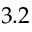Convert formula to latex. <formula><loc_0><loc_0><loc_500><loc_500>3 . 2</formula> 